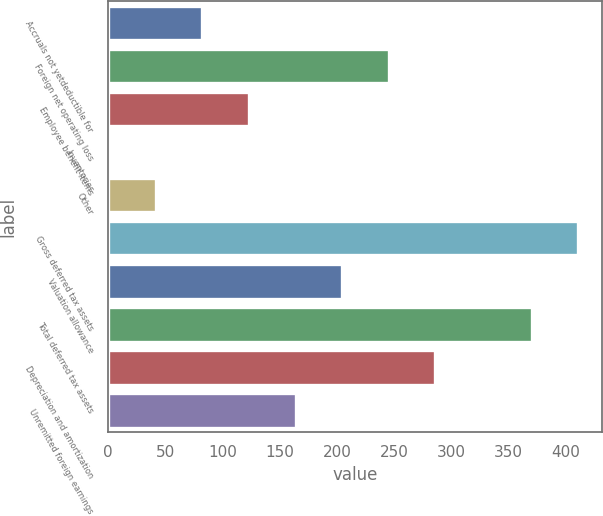Convert chart. <chart><loc_0><loc_0><loc_500><loc_500><bar_chart><fcel>Accruals not yetdeductible for<fcel>Foreign net operating loss<fcel>Employee benefit items<fcel>Inventories<fcel>Other<fcel>Gross deferred tax assets<fcel>Valuation allowance<fcel>Total deferred tax assets<fcel>Depreciation and amortization<fcel>Unremitted foreign earnings<nl><fcel>82.56<fcel>245.08<fcel>123.19<fcel>1.3<fcel>41.93<fcel>410.63<fcel>204.45<fcel>370<fcel>285.71<fcel>163.82<nl></chart> 